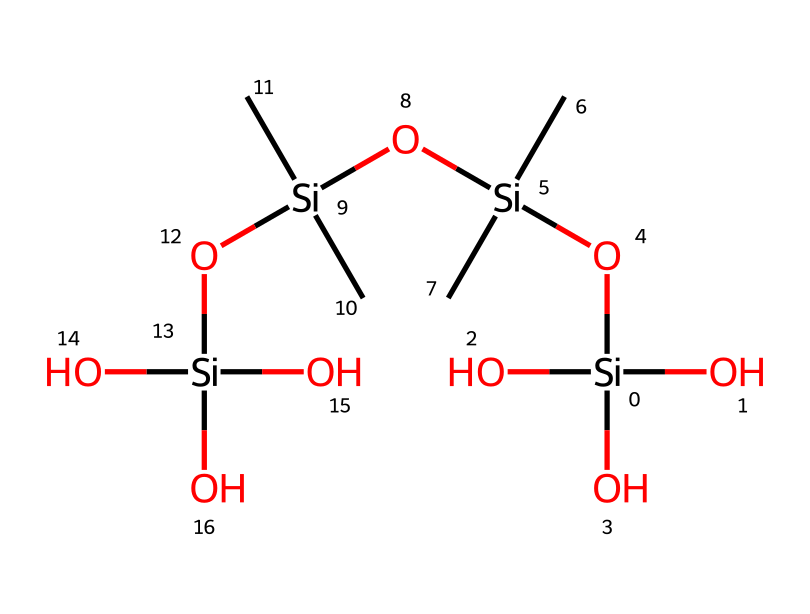What is the total number of silicon atoms in the chemical structure? The SMILES representation shows a total of 4 silicon atoms, counted directly from the structure as it appears.
Answer: 4 How many hydroxyl (-OH) groups are present in the compound? There are 4 hydroxyl groups in the structure, visible as the oxygen atoms attached to silicon that represent -OH.
Answer: 4 What is the total number of carbon atoms in the chemical? By analyzing the SMILES, there are 4 carbon atoms present, as indicated by the instances of "C" in the structure.
Answer: 4 Does this chemical contain any double bonds? The representation shows only single bonds connecting the silicon, oxygen, and carbon atoms, indicating that no double bonds are present.
Answer: no What properties of organosilicon compounds contribute to increased water retention in soils? The presence of hydroxyl groups in organosilicon compounds enhances hydrogen bonding with water, thereby improving water retention. This property is crucial for a fertilizer's effectiveness in retaining moisture in gardens.
Answer: hydrogen bonding What is the purpose of incorporating organosilicon compounds in fertilizers? Organosilicon compounds are added to fertilizers primarily to improve nutrient uptake and enhance soil structure, making them beneficial for plant growth.
Answer: improve nutrient uptake Can you identify the type of bonding between silicon and oxygen in this structure? The bonds between silicon and oxygen in this compound are predominantly covalent bonds, as silicon shares electrons with oxygen, forming strong connections characteristic of organosilicon compounds.
Answer: covalent bonds 